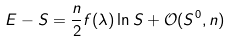<formula> <loc_0><loc_0><loc_500><loc_500>E - S = \frac { n } { 2 } f ( \lambda ) \ln S + \mathcal { O } ( S ^ { 0 } , n )</formula> 